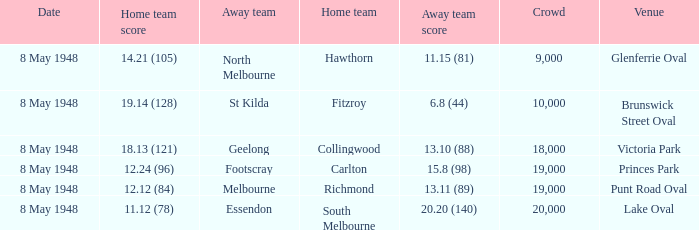Which away team played the home team when they scored 14.21 (105)? North Melbourne. 